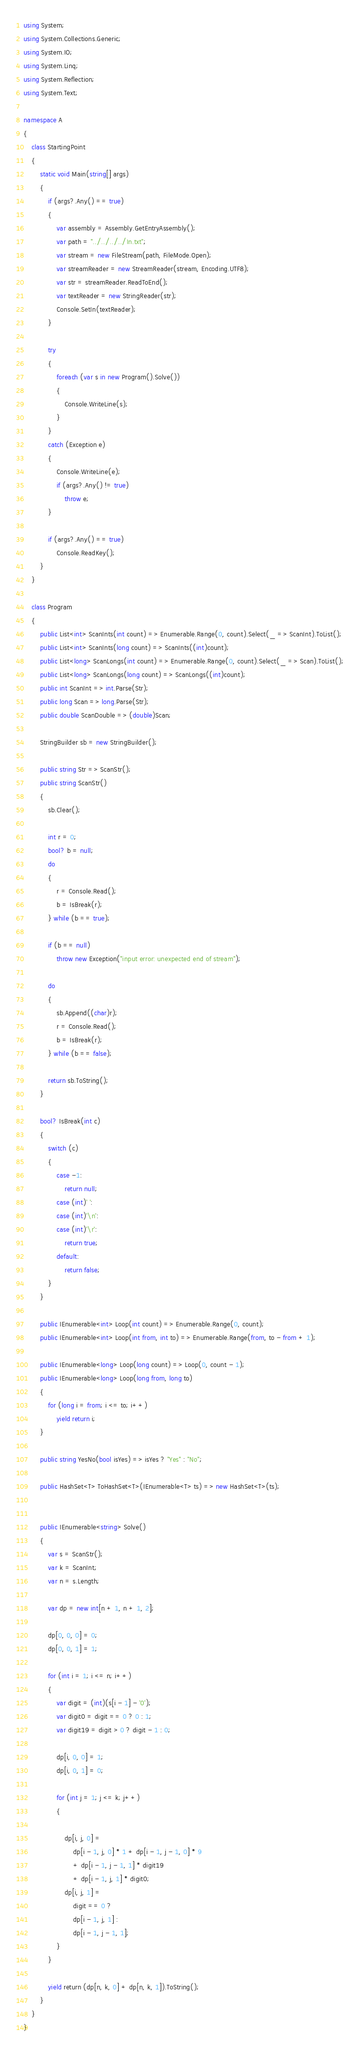Convert code to text. <code><loc_0><loc_0><loc_500><loc_500><_C#_>using System;
using System.Collections.Generic;
using System.IO;
using System.Linq;
using System.Reflection;
using System.Text;

namespace A
{
    class StartingPoint
    {
        static void Main(string[] args)
        {
            if (args?.Any() == true)
            {
                var assembly = Assembly.GetEntryAssembly();
                var path = "../../../../In.txt";
                var stream = new FileStream(path, FileMode.Open);
                var streamReader = new StreamReader(stream, Encoding.UTF8);
                var str = streamReader.ReadToEnd();
                var textReader = new StringReader(str);
                Console.SetIn(textReader);
            }

            try
            {
                foreach (var s in new Program().Solve())
                {
                    Console.WriteLine(s);
                }
            }
            catch (Exception e)
            {
                Console.WriteLine(e);
                if (args?.Any() != true)
                    throw e;
            }

            if (args?.Any() == true)
                Console.ReadKey();
        }
    }

    class Program
    {
        public List<int> ScanInts(int count) => Enumerable.Range(0, count).Select(_ => ScanInt).ToList();
        public List<int> ScanInts(long count) => ScanInts((int)count);
        public List<long> ScanLongs(int count) => Enumerable.Range(0, count).Select(_ => Scan).ToList();
        public List<long> ScanLongs(long count) => ScanLongs((int)count);
        public int ScanInt => int.Parse(Str);
        public long Scan => long.Parse(Str);
        public double ScanDouble => (double)Scan;

        StringBuilder sb = new StringBuilder();

        public string Str => ScanStr();
        public string ScanStr()
        {
            sb.Clear();

            int r = 0;
            bool? b = null;
            do
            {
                r = Console.Read();
                b = IsBreak(r);
            } while (b == true);

            if (b == null)
                throw new Exception("input error: unexpected end of stream");

            do
            {
                sb.Append((char)r);
                r = Console.Read();
                b = IsBreak(r);
            } while (b == false);

            return sb.ToString();
        }

        bool? IsBreak(int c)
        {
            switch (c)
            {
                case -1:
                    return null;
                case (int)' ':
                case (int)'\n':
                case (int)'\r':
                    return true;
                default:
                    return false;
            }
        }

        public IEnumerable<int> Loop(int count) => Enumerable.Range(0, count);
        public IEnumerable<int> Loop(int from, int to) => Enumerable.Range(from, to - from + 1);

        public IEnumerable<long> Loop(long count) => Loop(0, count - 1);
        public IEnumerable<long> Loop(long from, long to)
        {
            for (long i = from; i <= to; i++)
                yield return i;
        }

        public string YesNo(bool isYes) => isYes ? "Yes" : "No";

        public HashSet<T> ToHashSet<T>(IEnumerable<T> ts) => new HashSet<T>(ts);


        public IEnumerable<string> Solve()
        {
            var s = ScanStr();
            var k = ScanInt;
            var n = s.Length;

            var dp = new int[n + 1, n + 1, 2];

            dp[0, 0, 0] = 0;
            dp[0, 0, 1] = 1;

            for (int i = 1; i <= n; i++)
            {
                var digit = (int)(s[i - 1] - '0');
                var digit0 = digit == 0 ? 0 : 1;
                var digit19 = digit > 0 ? digit - 1 : 0;

                dp[i, 0, 0] = 1;
                dp[i, 0, 1] = 0;

                for (int j = 1; j <= k; j++)
                {

                    dp[i, j, 0] =
                        dp[i - 1, j, 0] * 1 + dp[i - 1, j - 1, 0] * 9
                        + dp[i - 1, j - 1, 1] * digit19
                        + dp[i - 1, j, 1] * digit0;
                    dp[i, j, 1] =
                        digit == 0 ?
                        dp[i - 1, j, 1] :
                        dp[i - 1, j - 1, 1];
                }
            }

            yield return (dp[n, k, 0] + dp[n, k, 1]).ToString();
        }
    }
}</code> 